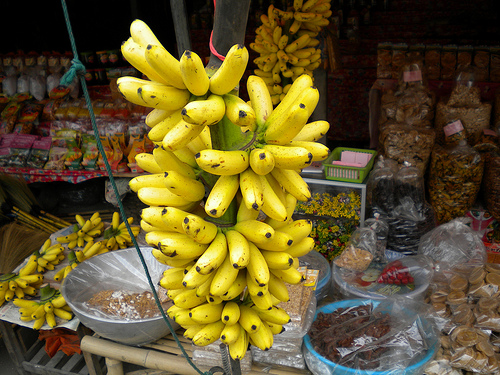Please provide a short description for this region: [0.15, 0.78, 0.6, 0.87]. The highlighted area portrays a well-used wooden table, evidencing the authentic and bustling nature of the local market experience. 